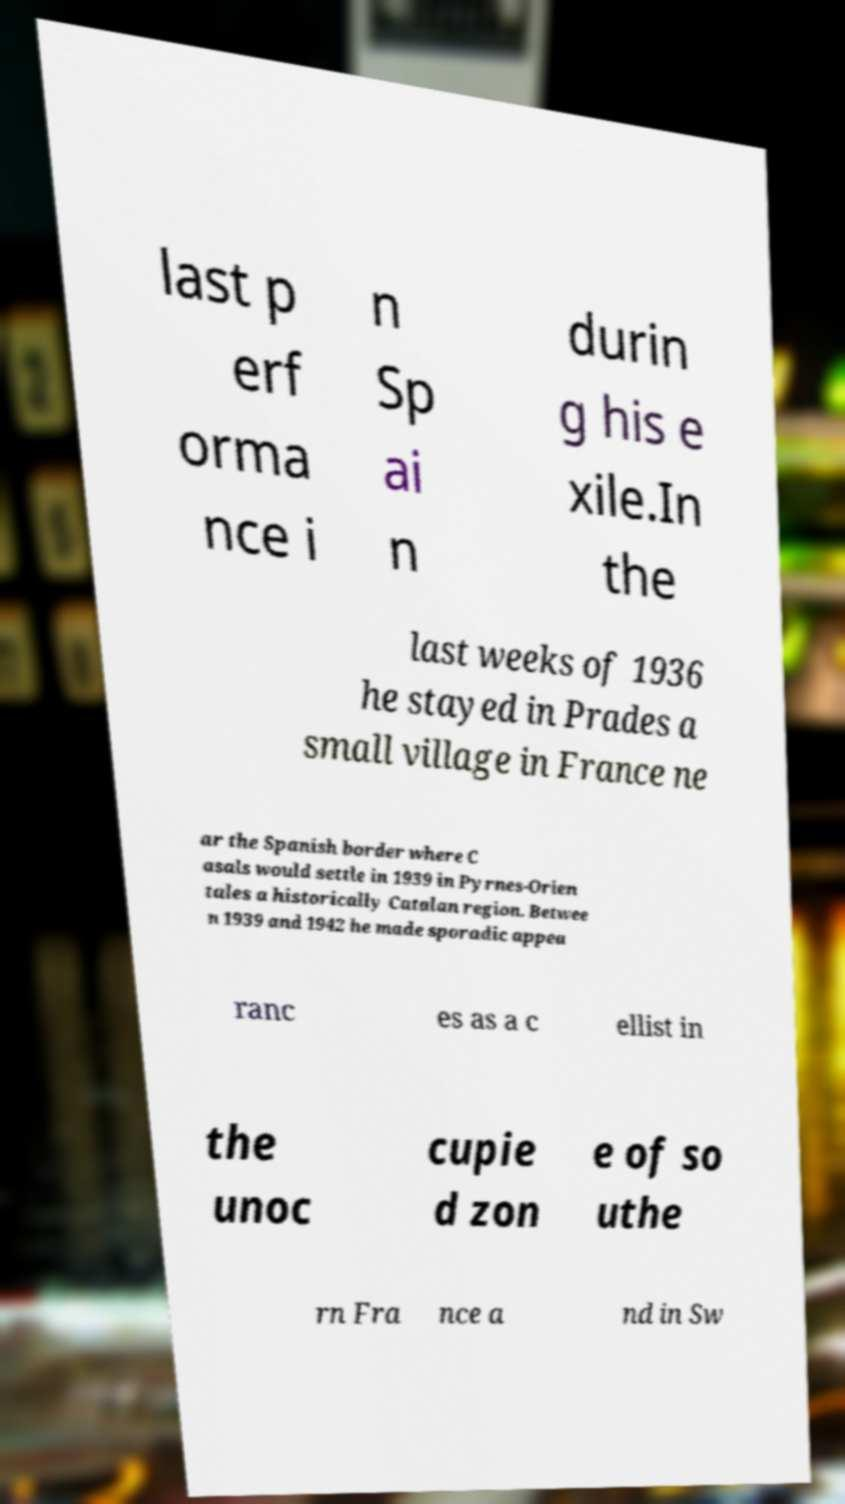Could you assist in decoding the text presented in this image and type it out clearly? last p erf orma nce i n Sp ai n durin g his e xile.In the last weeks of 1936 he stayed in Prades a small village in France ne ar the Spanish border where C asals would settle in 1939 in Pyrnes-Orien tales a historically Catalan region. Betwee n 1939 and 1942 he made sporadic appea ranc es as a c ellist in the unoc cupie d zon e of so uthe rn Fra nce a nd in Sw 